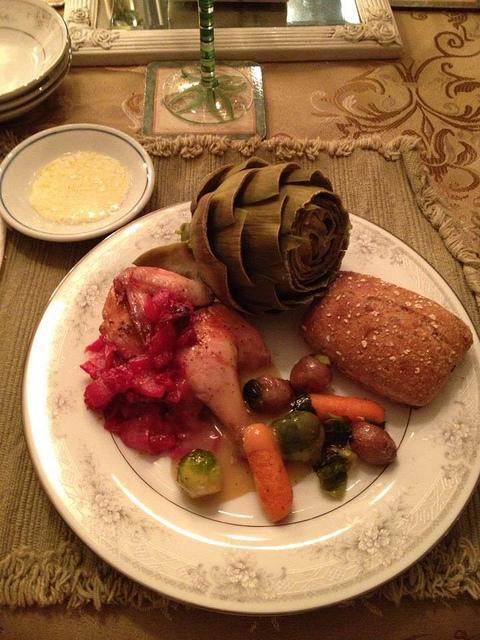Is there an artichoke?
Concise answer only. Yes. Does this place setting have silverware?
Answer briefly. No. What other green vegetable is pictured?
Give a very brief answer. Artichoke. 